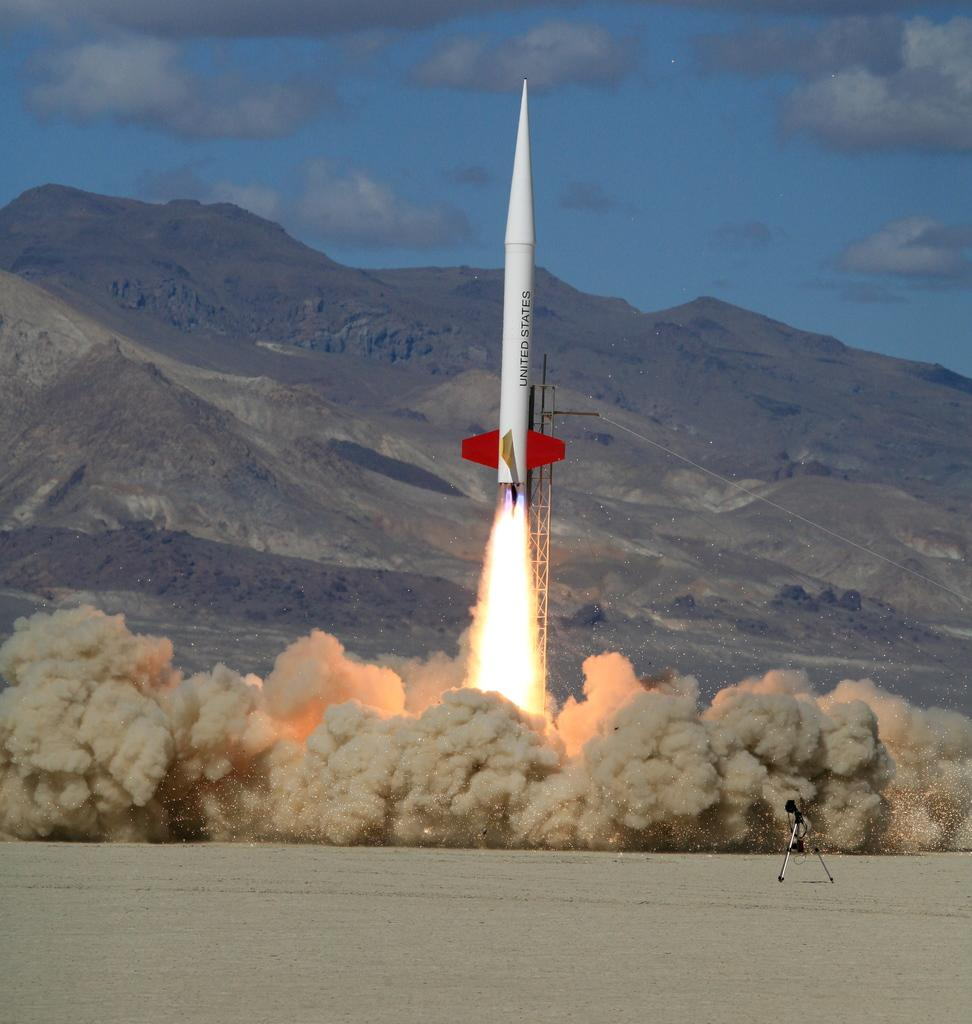<image>
Render a clear and concise summary of the photo. A United States rocket shoots off is a cloud of dust with fire trailing it. 